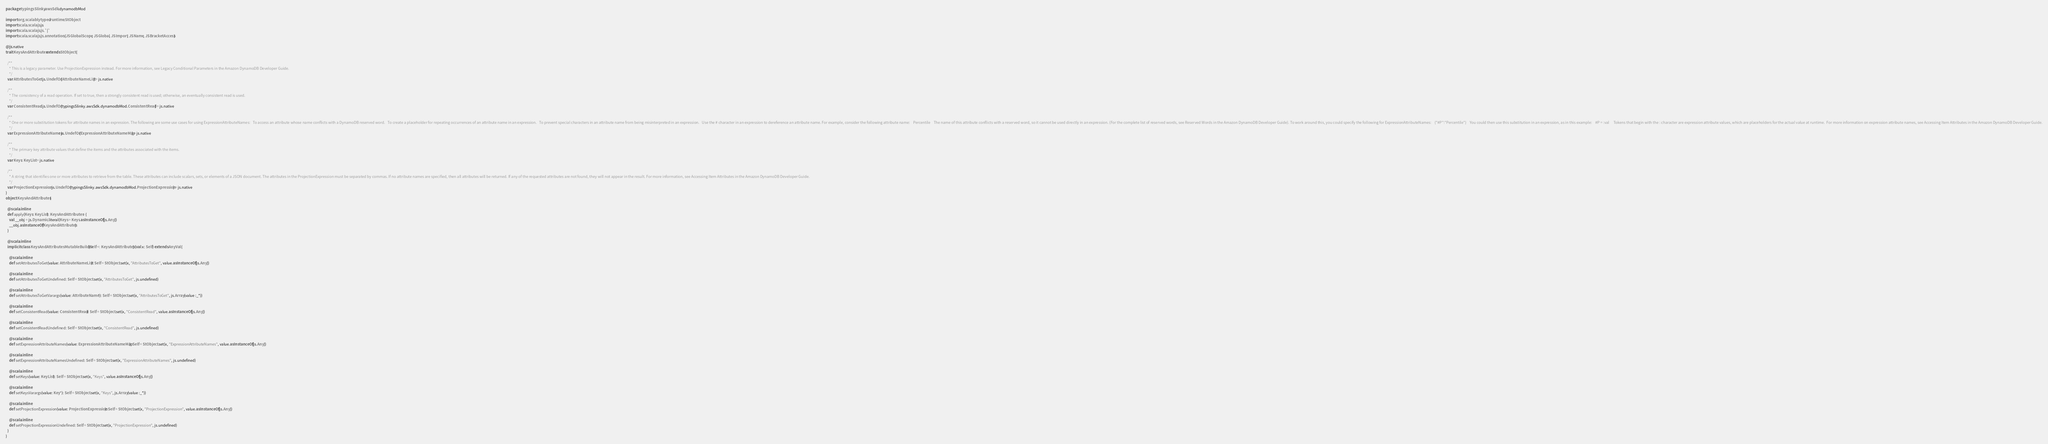<code> <loc_0><loc_0><loc_500><loc_500><_Scala_>package typingsSlinky.awsSdk.dynamodbMod

import org.scalablytyped.runtime.StObject
import scala.scalajs.js
import scala.scalajs.js.`|`
import scala.scalajs.js.annotation.{JSGlobalScope, JSGlobal, JSImport, JSName, JSBracketAccess}

@js.native
trait KeysAndAttributes extends StObject {
  
  /**
    * This is a legacy parameter. Use ProjectionExpression instead. For more information, see Legacy Conditional Parameters in the Amazon DynamoDB Developer Guide.
    */
  var AttributesToGet: js.UndefOr[AttributeNameList] = js.native
  
  /**
    * The consistency of a read operation. If set to true, then a strongly consistent read is used; otherwise, an eventually consistent read is used.
    */
  var ConsistentRead: js.UndefOr[typingsSlinky.awsSdk.dynamodbMod.ConsistentRead] = js.native
  
  /**
    * One or more substitution tokens for attribute names in an expression. The following are some use cases for using ExpressionAttributeNames:   To access an attribute whose name conflicts with a DynamoDB reserved word.   To create a placeholder for repeating occurrences of an attribute name in an expression.   To prevent special characters in an attribute name from being misinterpreted in an expression.   Use the # character in an expression to dereference an attribute name. For example, consider the following attribute name:    Percentile    The name of this attribute conflicts with a reserved word, so it cannot be used directly in an expression. (For the complete list of reserved words, see Reserved Words in the Amazon DynamoDB Developer Guide). To work around this, you could specify the following for ExpressionAttributeNames:    {"#P":"Percentile"}    You could then use this substitution in an expression, as in this example:    #P = :val     Tokens that begin with the : character are expression attribute values, which are placeholders for the actual value at runtime.  For more information on expression attribute names, see Accessing Item Attributes in the Amazon DynamoDB Developer Guide.
    */
  var ExpressionAttributeNames: js.UndefOr[ExpressionAttributeNameMap] = js.native
  
  /**
    * The primary key attribute values that define the items and the attributes associated with the items.
    */
  var Keys: KeyList = js.native
  
  /**
    * A string that identifies one or more attributes to retrieve from the table. These attributes can include scalars, sets, or elements of a JSON document. The attributes in the ProjectionExpression must be separated by commas. If no attribute names are specified, then all attributes will be returned. If any of the requested attributes are not found, they will not appear in the result. For more information, see Accessing Item Attributes in the Amazon DynamoDB Developer Guide.
    */
  var ProjectionExpression: js.UndefOr[typingsSlinky.awsSdk.dynamodbMod.ProjectionExpression] = js.native
}
object KeysAndAttributes {
  
  @scala.inline
  def apply(Keys: KeyList): KeysAndAttributes = {
    val __obj = js.Dynamic.literal(Keys = Keys.asInstanceOf[js.Any])
    __obj.asInstanceOf[KeysAndAttributes]
  }
  
  @scala.inline
  implicit class KeysAndAttributesMutableBuilder[Self <: KeysAndAttributes] (val x: Self) extends AnyVal {
    
    @scala.inline
    def setAttributesToGet(value: AttributeNameList): Self = StObject.set(x, "AttributesToGet", value.asInstanceOf[js.Any])
    
    @scala.inline
    def setAttributesToGetUndefined: Self = StObject.set(x, "AttributesToGet", js.undefined)
    
    @scala.inline
    def setAttributesToGetVarargs(value: AttributeName*): Self = StObject.set(x, "AttributesToGet", js.Array(value :_*))
    
    @scala.inline
    def setConsistentRead(value: ConsistentRead): Self = StObject.set(x, "ConsistentRead", value.asInstanceOf[js.Any])
    
    @scala.inline
    def setConsistentReadUndefined: Self = StObject.set(x, "ConsistentRead", js.undefined)
    
    @scala.inline
    def setExpressionAttributeNames(value: ExpressionAttributeNameMap): Self = StObject.set(x, "ExpressionAttributeNames", value.asInstanceOf[js.Any])
    
    @scala.inline
    def setExpressionAttributeNamesUndefined: Self = StObject.set(x, "ExpressionAttributeNames", js.undefined)
    
    @scala.inline
    def setKeys(value: KeyList): Self = StObject.set(x, "Keys", value.asInstanceOf[js.Any])
    
    @scala.inline
    def setKeysVarargs(value: Key*): Self = StObject.set(x, "Keys", js.Array(value :_*))
    
    @scala.inline
    def setProjectionExpression(value: ProjectionExpression): Self = StObject.set(x, "ProjectionExpression", value.asInstanceOf[js.Any])
    
    @scala.inline
    def setProjectionExpressionUndefined: Self = StObject.set(x, "ProjectionExpression", js.undefined)
  }
}
</code> 